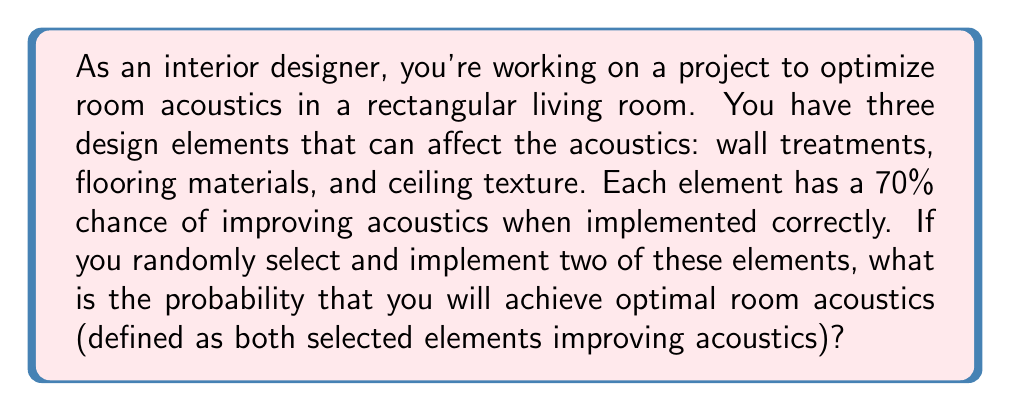Provide a solution to this math problem. Let's approach this step-by-step:

1) First, we need to calculate the probability of selecting any two elements out of three. This is always 1, as we are guaranteed to select two elements.

2) Now, for optimal acoustics, both selected elements need to improve acoustics. The probability of each element improving acoustics is 0.7 or 70%.

3) We can calculate this using the multiplication rule of probability:

   $P(\text{both elements improve}) = 0.7 \times 0.7 = 0.49$

4) However, this is just for one specific pair of elements. We need to consider all possible pairs.

5) There are three possible pairs of elements: (wall, floor), (wall, ceiling), (floor, ceiling). Each pair has a 0.49 probability of both elements improving acoustics.

6) The probability of achieving optimal acoustics is the same for each pair, so we can use the addition rule of probability:

   $P(\text{optimal acoustics}) = 0.49 + 0.49 + 0.49 = 1.47$

7) However, this sum exceeds 1, which is impossible for a probability. This is because we've counted each successful outcome three times (once for each pair).

8) To correct this, we need to divide our result by 3:

   $P(\text{optimal acoustics}) = \frac{1.47}{3} = 0.49$

Thus, the probability of achieving optimal room acoustics is 0.49 or 49%.
Answer: 0.49 